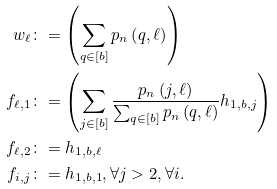Convert formula to latex. <formula><loc_0><loc_0><loc_500><loc_500>w _ { \ell } & \colon = \left ( \sum _ { q \in \left [ b \right ] } p _ { n } \left ( q , \ell \right ) \right ) \\ f _ { \ell , 1 } & \colon = \left ( \sum _ { j \in \left [ b \right ] } \frac { p _ { n } \left ( j , \ell \right ) } { \sum _ { q \in \left [ b \right ] } p _ { n } \left ( q , \ell \right ) } h _ { 1 , b , j } \right ) \\ f _ { \ell , 2 } & \colon = h _ { 1 , b , \ell } \\ f _ { i , j } & \colon = h _ { 1 , b , 1 } , \forall j > 2 , \forall i .</formula> 